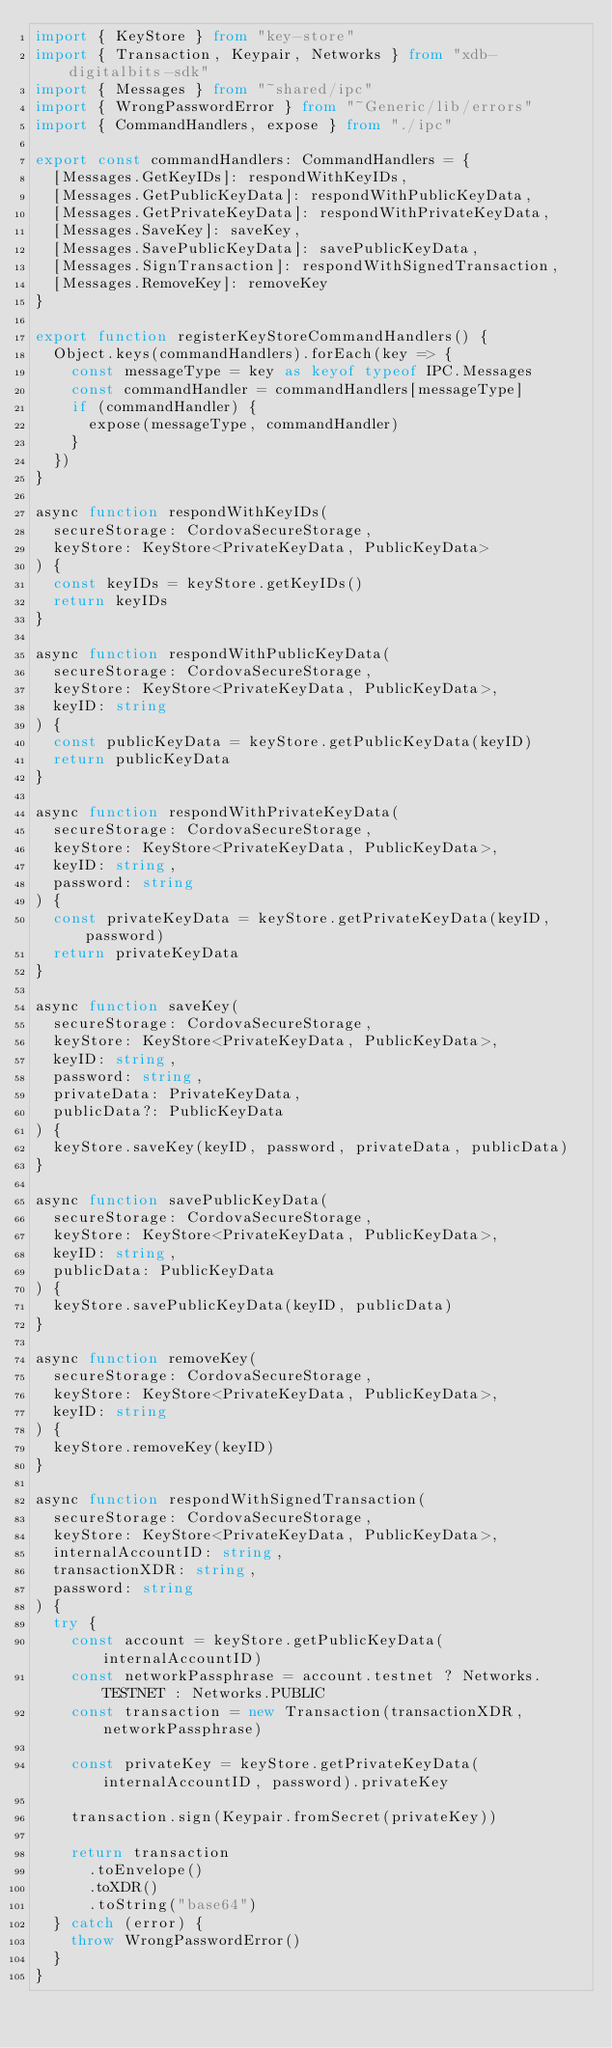Convert code to text. <code><loc_0><loc_0><loc_500><loc_500><_TypeScript_>import { KeyStore } from "key-store"
import { Transaction, Keypair, Networks } from "xdb-digitalbits-sdk"
import { Messages } from "~shared/ipc"
import { WrongPasswordError } from "~Generic/lib/errors"
import { CommandHandlers, expose } from "./ipc"

export const commandHandlers: CommandHandlers = {
  [Messages.GetKeyIDs]: respondWithKeyIDs,
  [Messages.GetPublicKeyData]: respondWithPublicKeyData,
  [Messages.GetPrivateKeyData]: respondWithPrivateKeyData,
  [Messages.SaveKey]: saveKey,
  [Messages.SavePublicKeyData]: savePublicKeyData,
  [Messages.SignTransaction]: respondWithSignedTransaction,
  [Messages.RemoveKey]: removeKey
}

export function registerKeyStoreCommandHandlers() {
  Object.keys(commandHandlers).forEach(key => {
    const messageType = key as keyof typeof IPC.Messages
    const commandHandler = commandHandlers[messageType]
    if (commandHandler) {
      expose(messageType, commandHandler)
    }
  })
}

async function respondWithKeyIDs(
  secureStorage: CordovaSecureStorage,
  keyStore: KeyStore<PrivateKeyData, PublicKeyData>
) {
  const keyIDs = keyStore.getKeyIDs()
  return keyIDs
}

async function respondWithPublicKeyData(
  secureStorage: CordovaSecureStorage,
  keyStore: KeyStore<PrivateKeyData, PublicKeyData>,
  keyID: string
) {
  const publicKeyData = keyStore.getPublicKeyData(keyID)
  return publicKeyData
}

async function respondWithPrivateKeyData(
  secureStorage: CordovaSecureStorage,
  keyStore: KeyStore<PrivateKeyData, PublicKeyData>,
  keyID: string,
  password: string
) {
  const privateKeyData = keyStore.getPrivateKeyData(keyID, password)
  return privateKeyData
}

async function saveKey(
  secureStorage: CordovaSecureStorage,
  keyStore: KeyStore<PrivateKeyData, PublicKeyData>,
  keyID: string,
  password: string,
  privateData: PrivateKeyData,
  publicData?: PublicKeyData
) {
  keyStore.saveKey(keyID, password, privateData, publicData)
}

async function savePublicKeyData(
  secureStorage: CordovaSecureStorage,
  keyStore: KeyStore<PrivateKeyData, PublicKeyData>,
  keyID: string,
  publicData: PublicKeyData
) {
  keyStore.savePublicKeyData(keyID, publicData)
}

async function removeKey(
  secureStorage: CordovaSecureStorage,
  keyStore: KeyStore<PrivateKeyData, PublicKeyData>,
  keyID: string
) {
  keyStore.removeKey(keyID)
}

async function respondWithSignedTransaction(
  secureStorage: CordovaSecureStorage,
  keyStore: KeyStore<PrivateKeyData, PublicKeyData>,
  internalAccountID: string,
  transactionXDR: string,
  password: string
) {
  try {
    const account = keyStore.getPublicKeyData(internalAccountID)
    const networkPassphrase = account.testnet ? Networks.TESTNET : Networks.PUBLIC
    const transaction = new Transaction(transactionXDR, networkPassphrase)

    const privateKey = keyStore.getPrivateKeyData(internalAccountID, password).privateKey

    transaction.sign(Keypair.fromSecret(privateKey))

    return transaction
      .toEnvelope()
      .toXDR()
      .toString("base64")
  } catch (error) {
    throw WrongPasswordError()
  }
}
</code> 